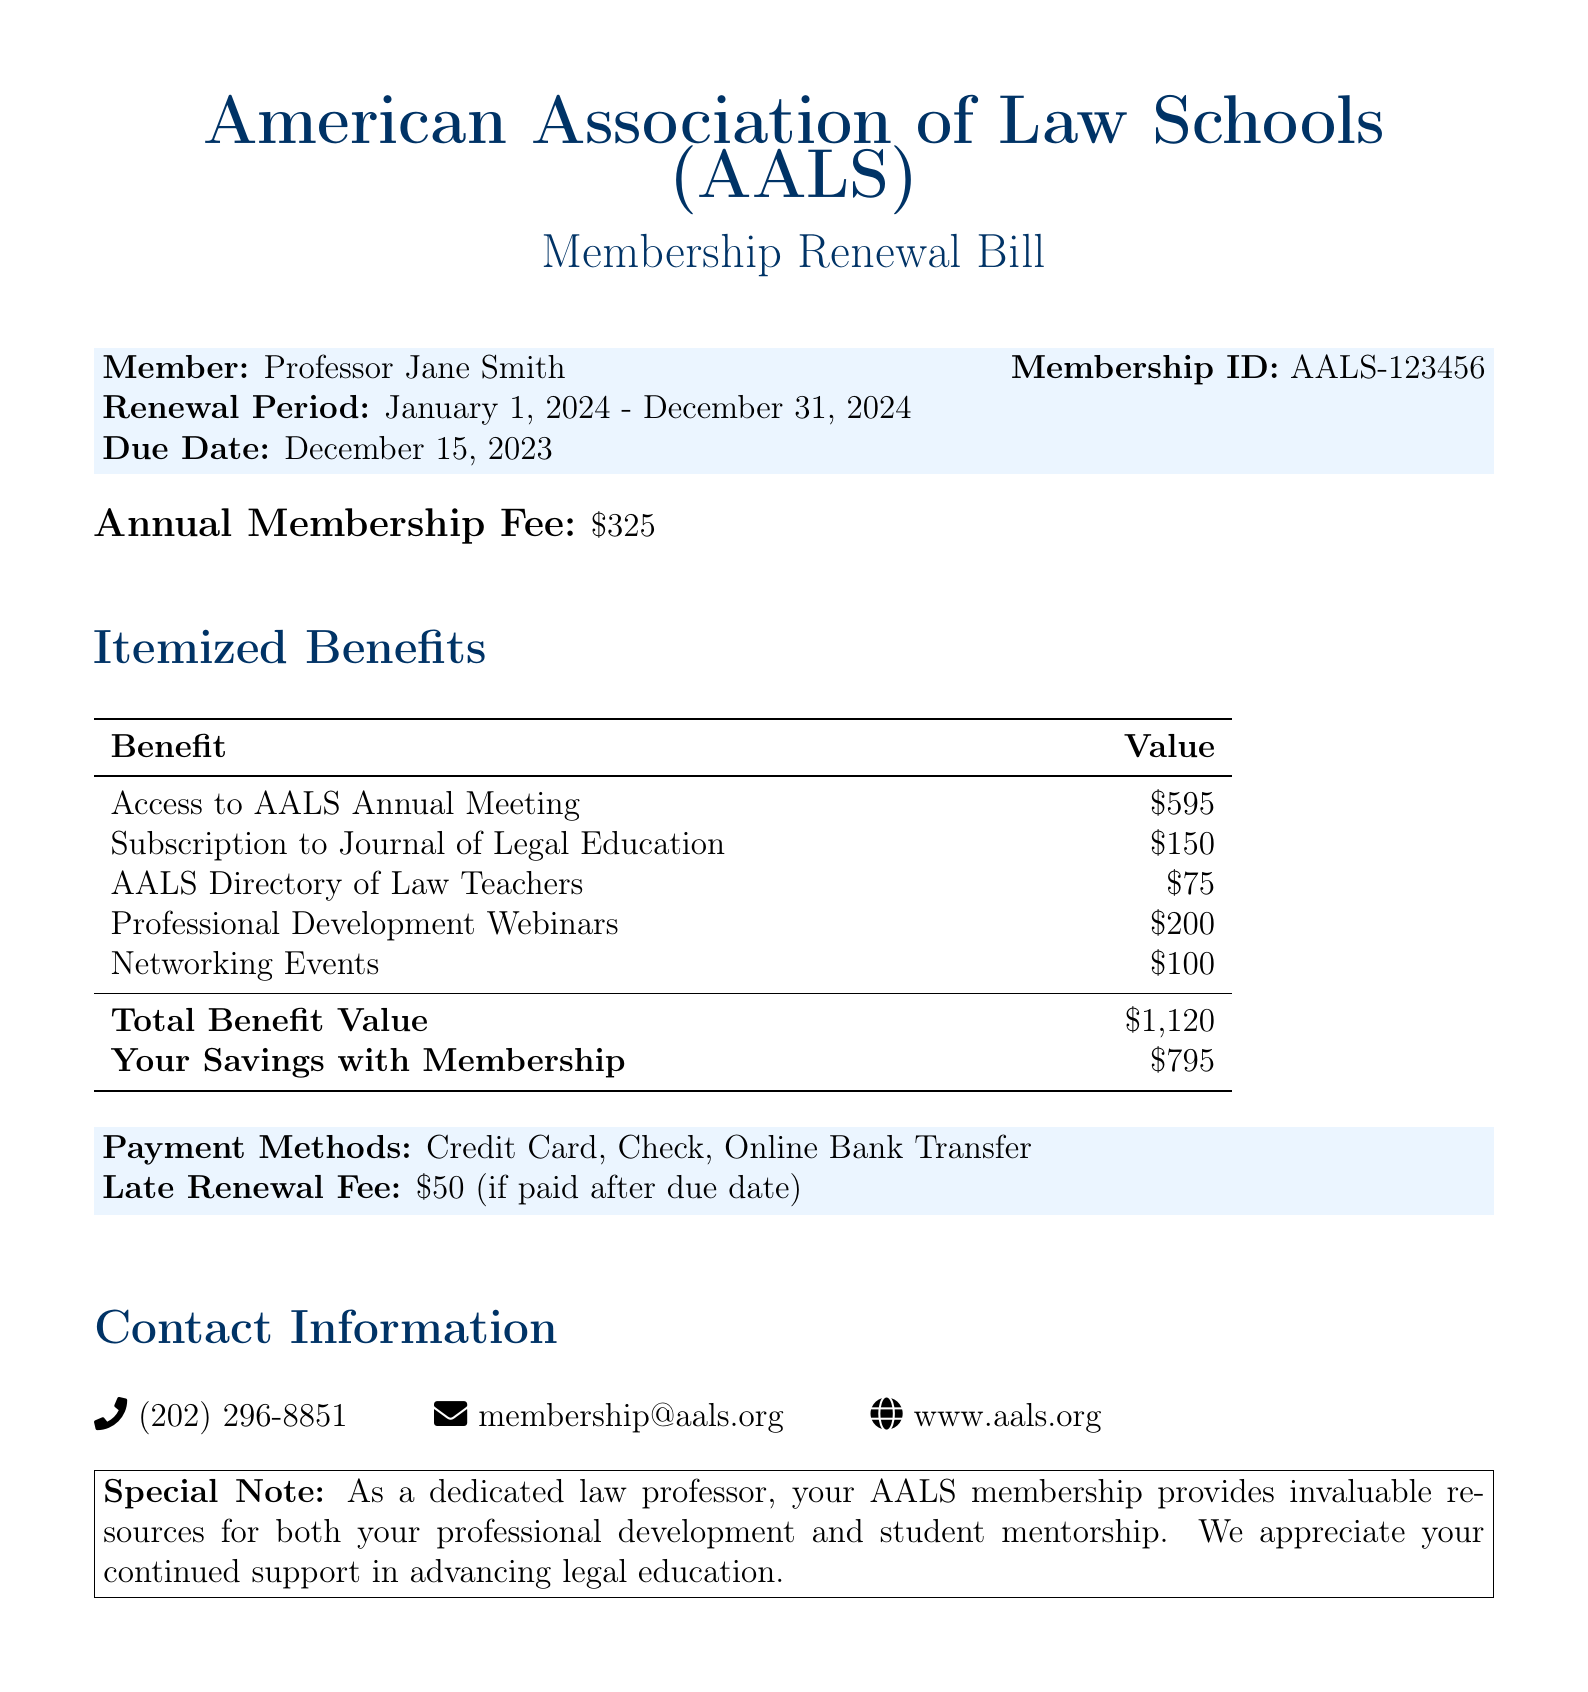What is the membership ID? The document lists the membership ID under the member's details, which is AALS-123456.
Answer: AALS-123456 What is the renewal period? The renewal period is specified clearly in the member's details section of the document.
Answer: January 1, 2024 - December 31, 2024 What is the annual membership fee? The document states the annual membership fee, which is indicated beneath the member's details.
Answer: $325 What is the total benefit value? This information is provided in the itemized benefits table that summarizes the total value of benefits provided.
Answer: $1,120 What is the late renewal fee? Information regarding any penalties for late payment is mentioned towards the end of the document.
Answer: $50 What is the total savings with membership? The document specifies this in the itemized benefits section, showing how much a member saves with their membership.
Answer: $795 Which resource has a value of $150? The document itemizes different benefits, and this amount corresponds to a specific resource listed in the benefits table.
Answer: Subscription to Journal of Legal Education How can payment be made? The document contains a section that mentions acceptable methods for payment in detail.
Answer: Credit Card, Check, Online Bank Transfer What is the purpose of the special note? The special note is outlined to convey the importance of the AALS membership for law professors specifically.
Answer: Invaluable resources for professional development and student mentorship Who is the member listed in the document? The member's name is indicated at the top of the member details.
Answer: Professor Jane Smith 